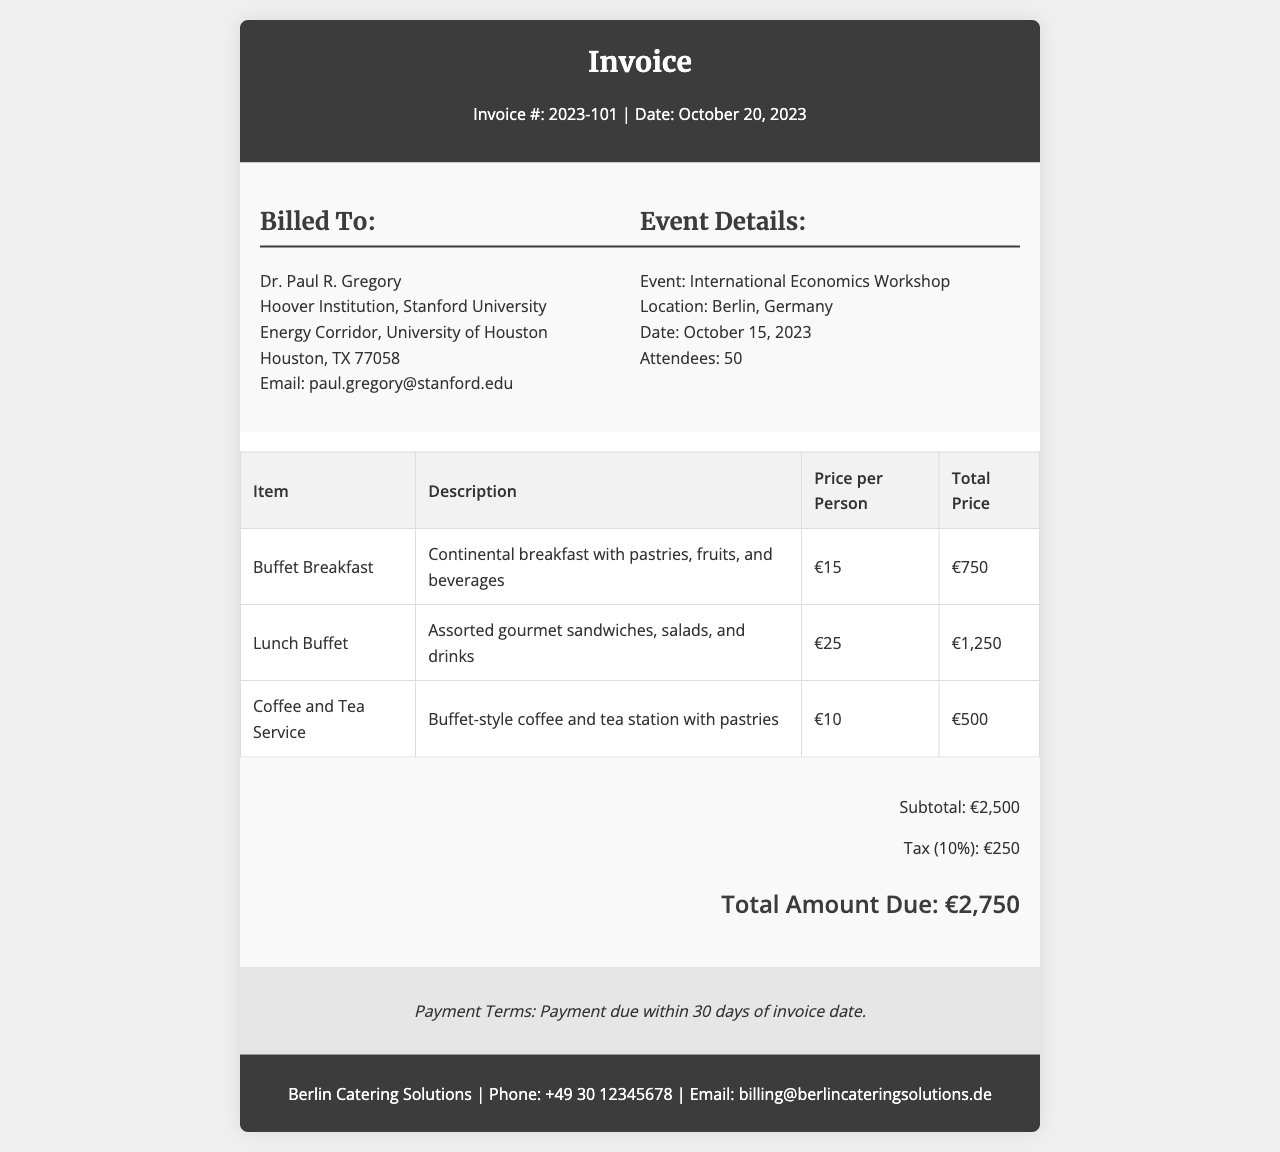What is the invoice number? The invoice number is specified in the header of the document as Invoice #: 2023-101.
Answer: 2023-101 What is the date of the invoice? The date of the invoice is mentioned in the header section of the document as Date: October 20, 2023.
Answer: October 20, 2023 What is the total amount due? The total amount due is calculated and mentioned in the total section of the document as Total Amount Due: €2,750.
Answer: €2,750 How many attendees were at the workshop? The number of attendees is stated in the event details section of the document as Attendees: 50.
Answer: 50 What was served for the Buffet Breakfast? The description for the Buffet Breakfast mentions it includes pastries, fruits, and beverages.
Answer: Pastries, fruits, and beverages What is the tax percentage applied? The tax percentage is noted in the total section of the invoice as 10%.
Answer: 10% What is the due date for the payment? The payment terms state that payment is due within 30 days of the invoice date.
Answer: 30 days What is the location of the event? The event location is specified in the event details section as Berlin, Germany.
Answer: Berlin, Germany What was the price per person for Lunch Buffet? The price per person for the Lunch Buffet is provided in the services table as €25.
Answer: €25 